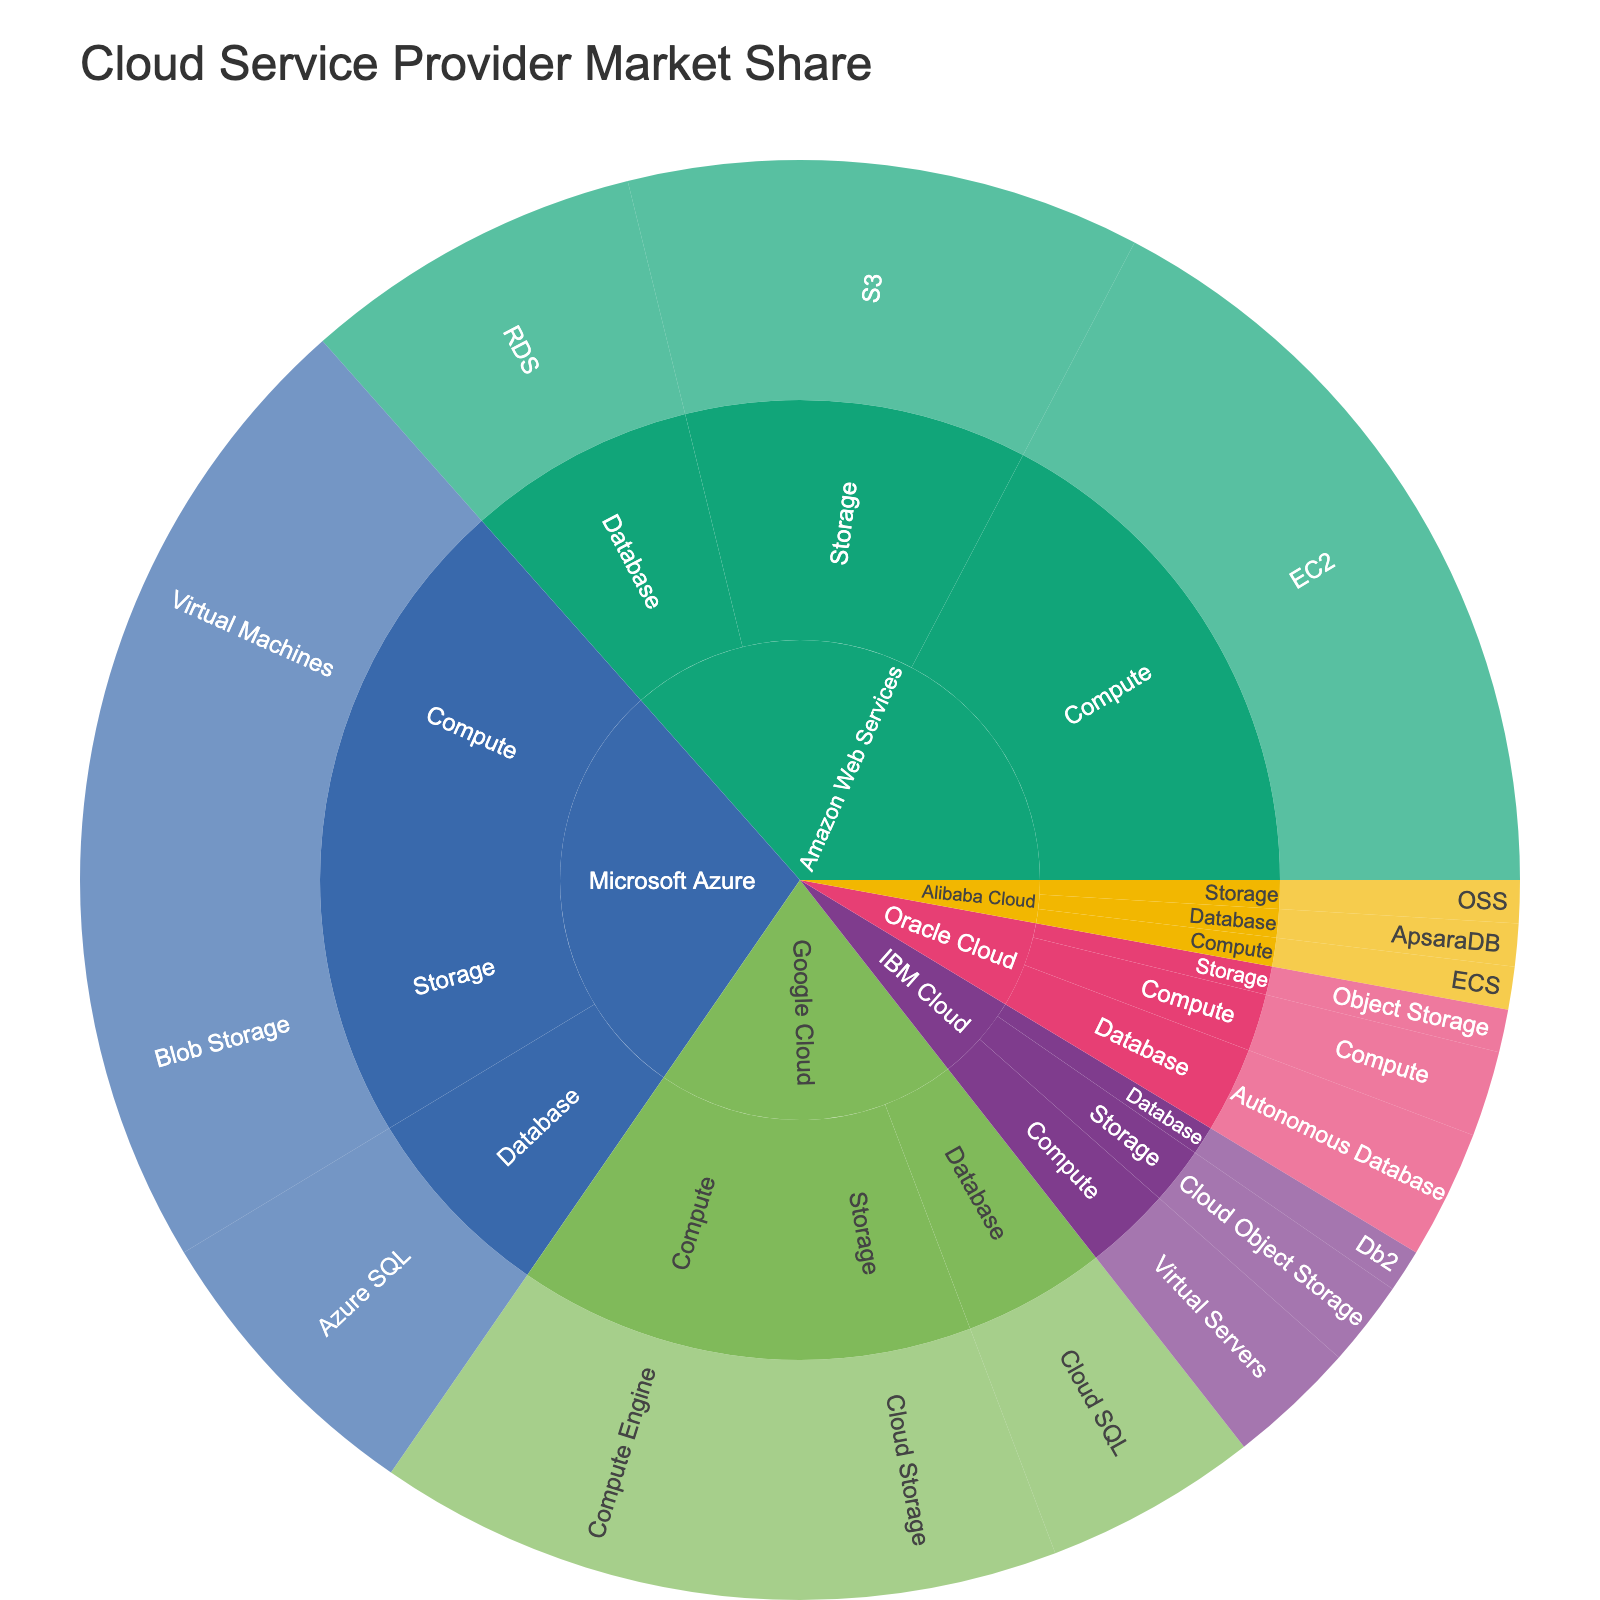What is the market share of Amazon Web Services? Look at the sunburst plot and sum the market shares of all services offered by Amazon Web Services (EC2, S3, RDS): 18% (EC2) + 12% (S3) + 8% (RDS) = 38%
Answer: 38% Which cloud provider offers the most services in the compute category? Compare the number of services in the compute category for each cloud provider in the sunburst plot. Amazon Web Services (EC2), Microsoft Azure (Virtual Machines), Google Cloud (Compute Engine), IBM Cloud (Virtual Servers), Oracle Cloud (Compute), and Alibaba Cloud (ECS) each offer one service in compute. Therefore, they all offer an equal number of services.
Answer: All offer 1 What is the total market share of storage services across all providers? Look at the sunburst plot and sum the market shares of storage services from all cloud providers: 12% (S3) + 9% (Blob Storage) + 6% (Cloud Storage) + 2% (Cloud Object Storage) + 1% (Object Storage) + 1% (OSS) = 31%
Answer: 31% Which cloud provider has the smallest overall market share? Look at the sum of market shares for each cloud provider in the sunburst plot. Alibaba Cloud has the smallest market share with 1% (ECS) + 1% (OSS) + 1% (ApsaraDB) = 3%
Answer: Alibaba Cloud How does the market share of database services compare between Microsoft Azure and Google Cloud? Look at the sunburst plot and compare the market shares of database services for Microsoft Azure (7%) and Google Cloud (5%). Microsoft Azure has a higher market share in database services.
Answer: Microsoft Azure What is the market share for Google Cloud's Compute Engine? Look at the sunburst plot to find the market share for Compute Engine under Google Cloud's compute category, which is 10%.
Answer: 10% Compare the market share of storage services between Amazon Web Services and Microsoft Azure. Look at the sunburst plot and compare the market shares of storage services: Amazon Web Services (S3) has 12%, and Microsoft Azure (Blob Storage) has 9%. Therefore, Amazon Web Services has a higher market share in storage services.
Answer: Amazon Web Services What is the combined market share of database services offered by IBM Cloud and Oracle Cloud? Look at the sunburst plot and sum the market shares of database services for IBM Cloud (1% Db2) and Oracle Cloud (3% Autonomous Database): 1% + 3% = 4%
Answer: 4% Which specific service has the highest individual market share? Look at the sunburst plot to find the specific service with the highest market share. Amazon Web Services' EC2 has the highest individual market share of 18%.
Answer: EC2 What is the total market share of compute services offered by Amazon Web Services and Microsoft Azure? Look at the sunburst plot and sum the market shares of compute services for Amazon Web Services (18% EC2) and Microsoft Azure (14% Virtual Machines): 18% + 14% = 32%
Answer: 32% 